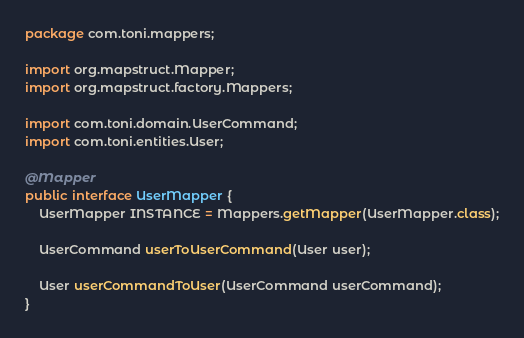<code> <loc_0><loc_0><loc_500><loc_500><_Java_>package com.toni.mappers;

import org.mapstruct.Mapper;
import org.mapstruct.factory.Mappers;

import com.toni.domain.UserCommand;
import com.toni.entities.User;

@Mapper
public interface UserMapper {
    UserMapper INSTANCE = Mappers.getMapper(UserMapper.class);

    UserCommand userToUserCommand(User user);

    User userCommandToUser(UserCommand userCommand);
}</code> 